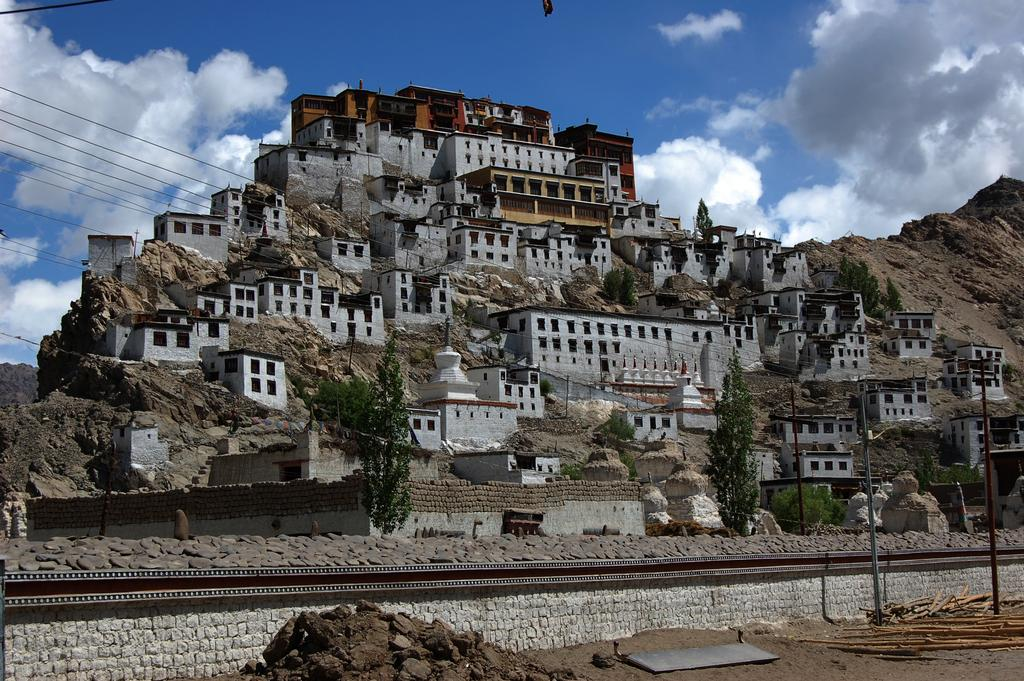What type of structures can be seen in the image? There are buildings on the hills in the image. What else is visible in the image besides the buildings? There is a track visible in the image. What type of juice is being served at the son's birthday party in the image? There is no son or birthday party present in the image; it only features buildings on hills and a track. 